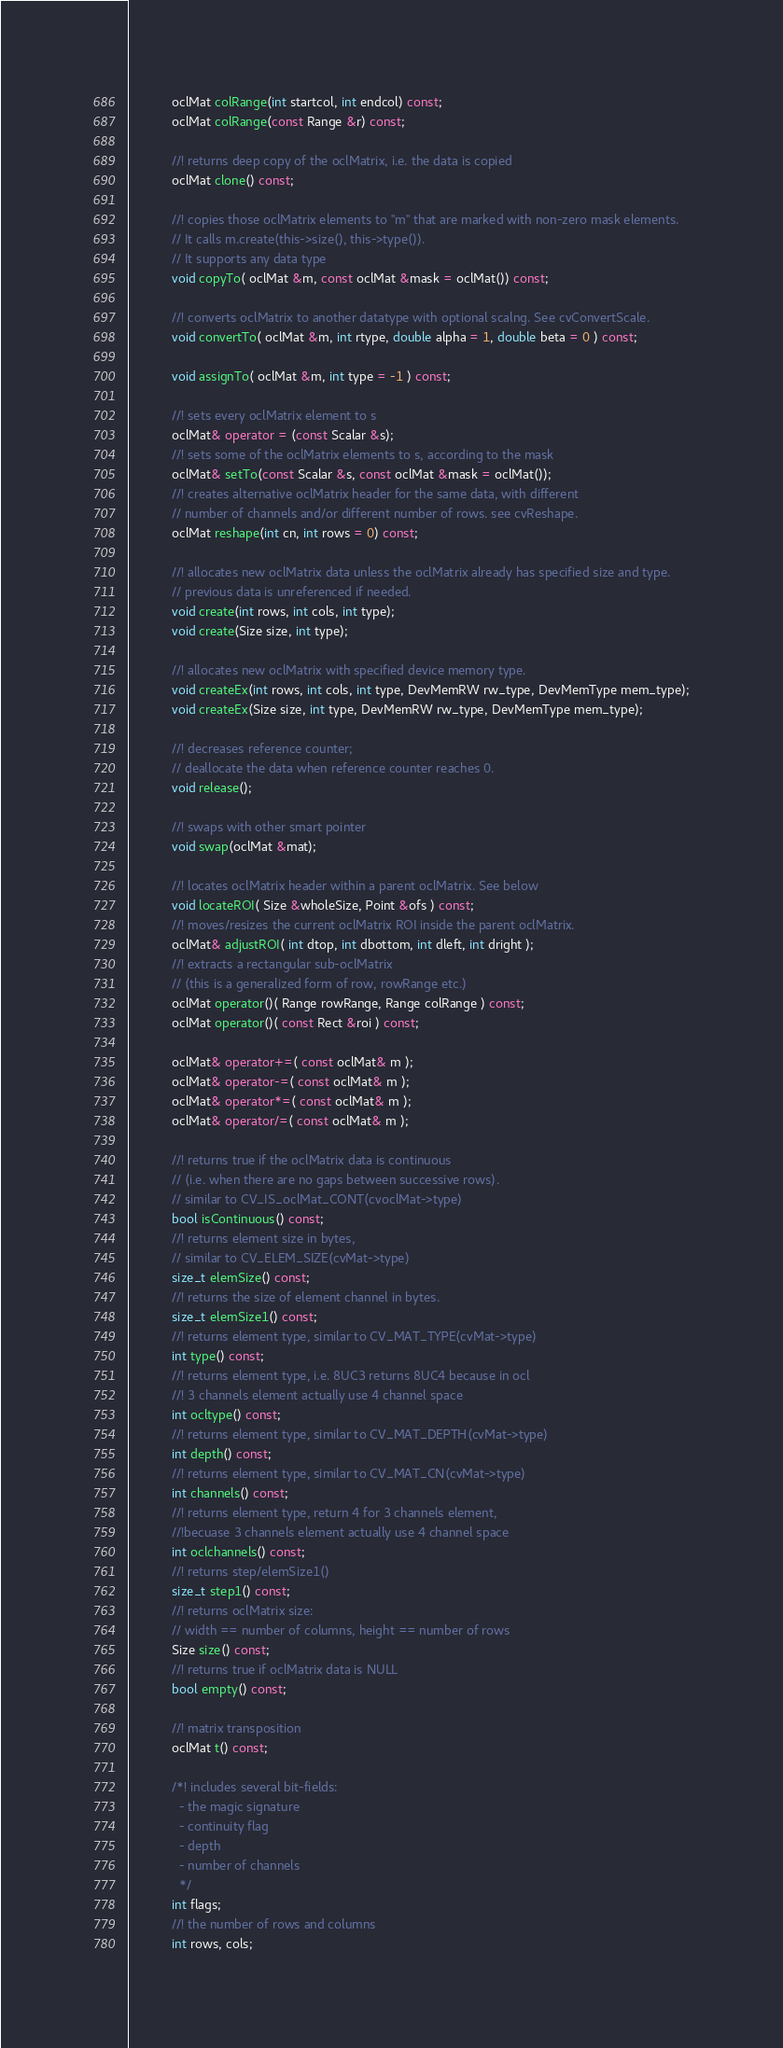Convert code to text. <code><loc_0><loc_0><loc_500><loc_500><_C++_>            oclMat colRange(int startcol, int endcol) const;
            oclMat colRange(const Range &r) const;

            //! returns deep copy of the oclMatrix, i.e. the data is copied
            oclMat clone() const;

            //! copies those oclMatrix elements to "m" that are marked with non-zero mask elements.
            // It calls m.create(this->size(), this->type()).
            // It supports any data type
            void copyTo( oclMat &m, const oclMat &mask = oclMat()) const;

            //! converts oclMatrix to another datatype with optional scalng. See cvConvertScale.
            void convertTo( oclMat &m, int rtype, double alpha = 1, double beta = 0 ) const;

            void assignTo( oclMat &m, int type = -1 ) const;

            //! sets every oclMatrix element to s
            oclMat& operator = (const Scalar &s);
            //! sets some of the oclMatrix elements to s, according to the mask
            oclMat& setTo(const Scalar &s, const oclMat &mask = oclMat());
            //! creates alternative oclMatrix header for the same data, with different
            // number of channels and/or different number of rows. see cvReshape.
            oclMat reshape(int cn, int rows = 0) const;

            //! allocates new oclMatrix data unless the oclMatrix already has specified size and type.
            // previous data is unreferenced if needed.
            void create(int rows, int cols, int type);
            void create(Size size, int type);

            //! allocates new oclMatrix with specified device memory type.
            void createEx(int rows, int cols, int type, DevMemRW rw_type, DevMemType mem_type);
            void createEx(Size size, int type, DevMemRW rw_type, DevMemType mem_type);

            //! decreases reference counter;
            // deallocate the data when reference counter reaches 0.
            void release();

            //! swaps with other smart pointer
            void swap(oclMat &mat);

            //! locates oclMatrix header within a parent oclMatrix. See below
            void locateROI( Size &wholeSize, Point &ofs ) const;
            //! moves/resizes the current oclMatrix ROI inside the parent oclMatrix.
            oclMat& adjustROI( int dtop, int dbottom, int dleft, int dright );
            //! extracts a rectangular sub-oclMatrix
            // (this is a generalized form of row, rowRange etc.)
            oclMat operator()( Range rowRange, Range colRange ) const;
            oclMat operator()( const Rect &roi ) const;

            oclMat& operator+=( const oclMat& m );
            oclMat& operator-=( const oclMat& m );
            oclMat& operator*=( const oclMat& m );
            oclMat& operator/=( const oclMat& m );

            //! returns true if the oclMatrix data is continuous
            // (i.e. when there are no gaps between successive rows).
            // similar to CV_IS_oclMat_CONT(cvoclMat->type)
            bool isContinuous() const;
            //! returns element size in bytes,
            // similar to CV_ELEM_SIZE(cvMat->type)
            size_t elemSize() const;
            //! returns the size of element channel in bytes.
            size_t elemSize1() const;
            //! returns element type, similar to CV_MAT_TYPE(cvMat->type)
            int type() const;
            //! returns element type, i.e. 8UC3 returns 8UC4 because in ocl
            //! 3 channels element actually use 4 channel space
            int ocltype() const;
            //! returns element type, similar to CV_MAT_DEPTH(cvMat->type)
            int depth() const;
            //! returns element type, similar to CV_MAT_CN(cvMat->type)
            int channels() const;
            //! returns element type, return 4 for 3 channels element,
            //!becuase 3 channels element actually use 4 channel space
            int oclchannels() const;
            //! returns step/elemSize1()
            size_t step1() const;
            //! returns oclMatrix size:
            // width == number of columns, height == number of rows
            Size size() const;
            //! returns true if oclMatrix data is NULL
            bool empty() const;

            //! matrix transposition
            oclMat t() const;

            /*! includes several bit-fields:
              - the magic signature
              - continuity flag
              - depth
              - number of channels
              */
            int flags;
            //! the number of rows and columns
            int rows, cols;</code> 